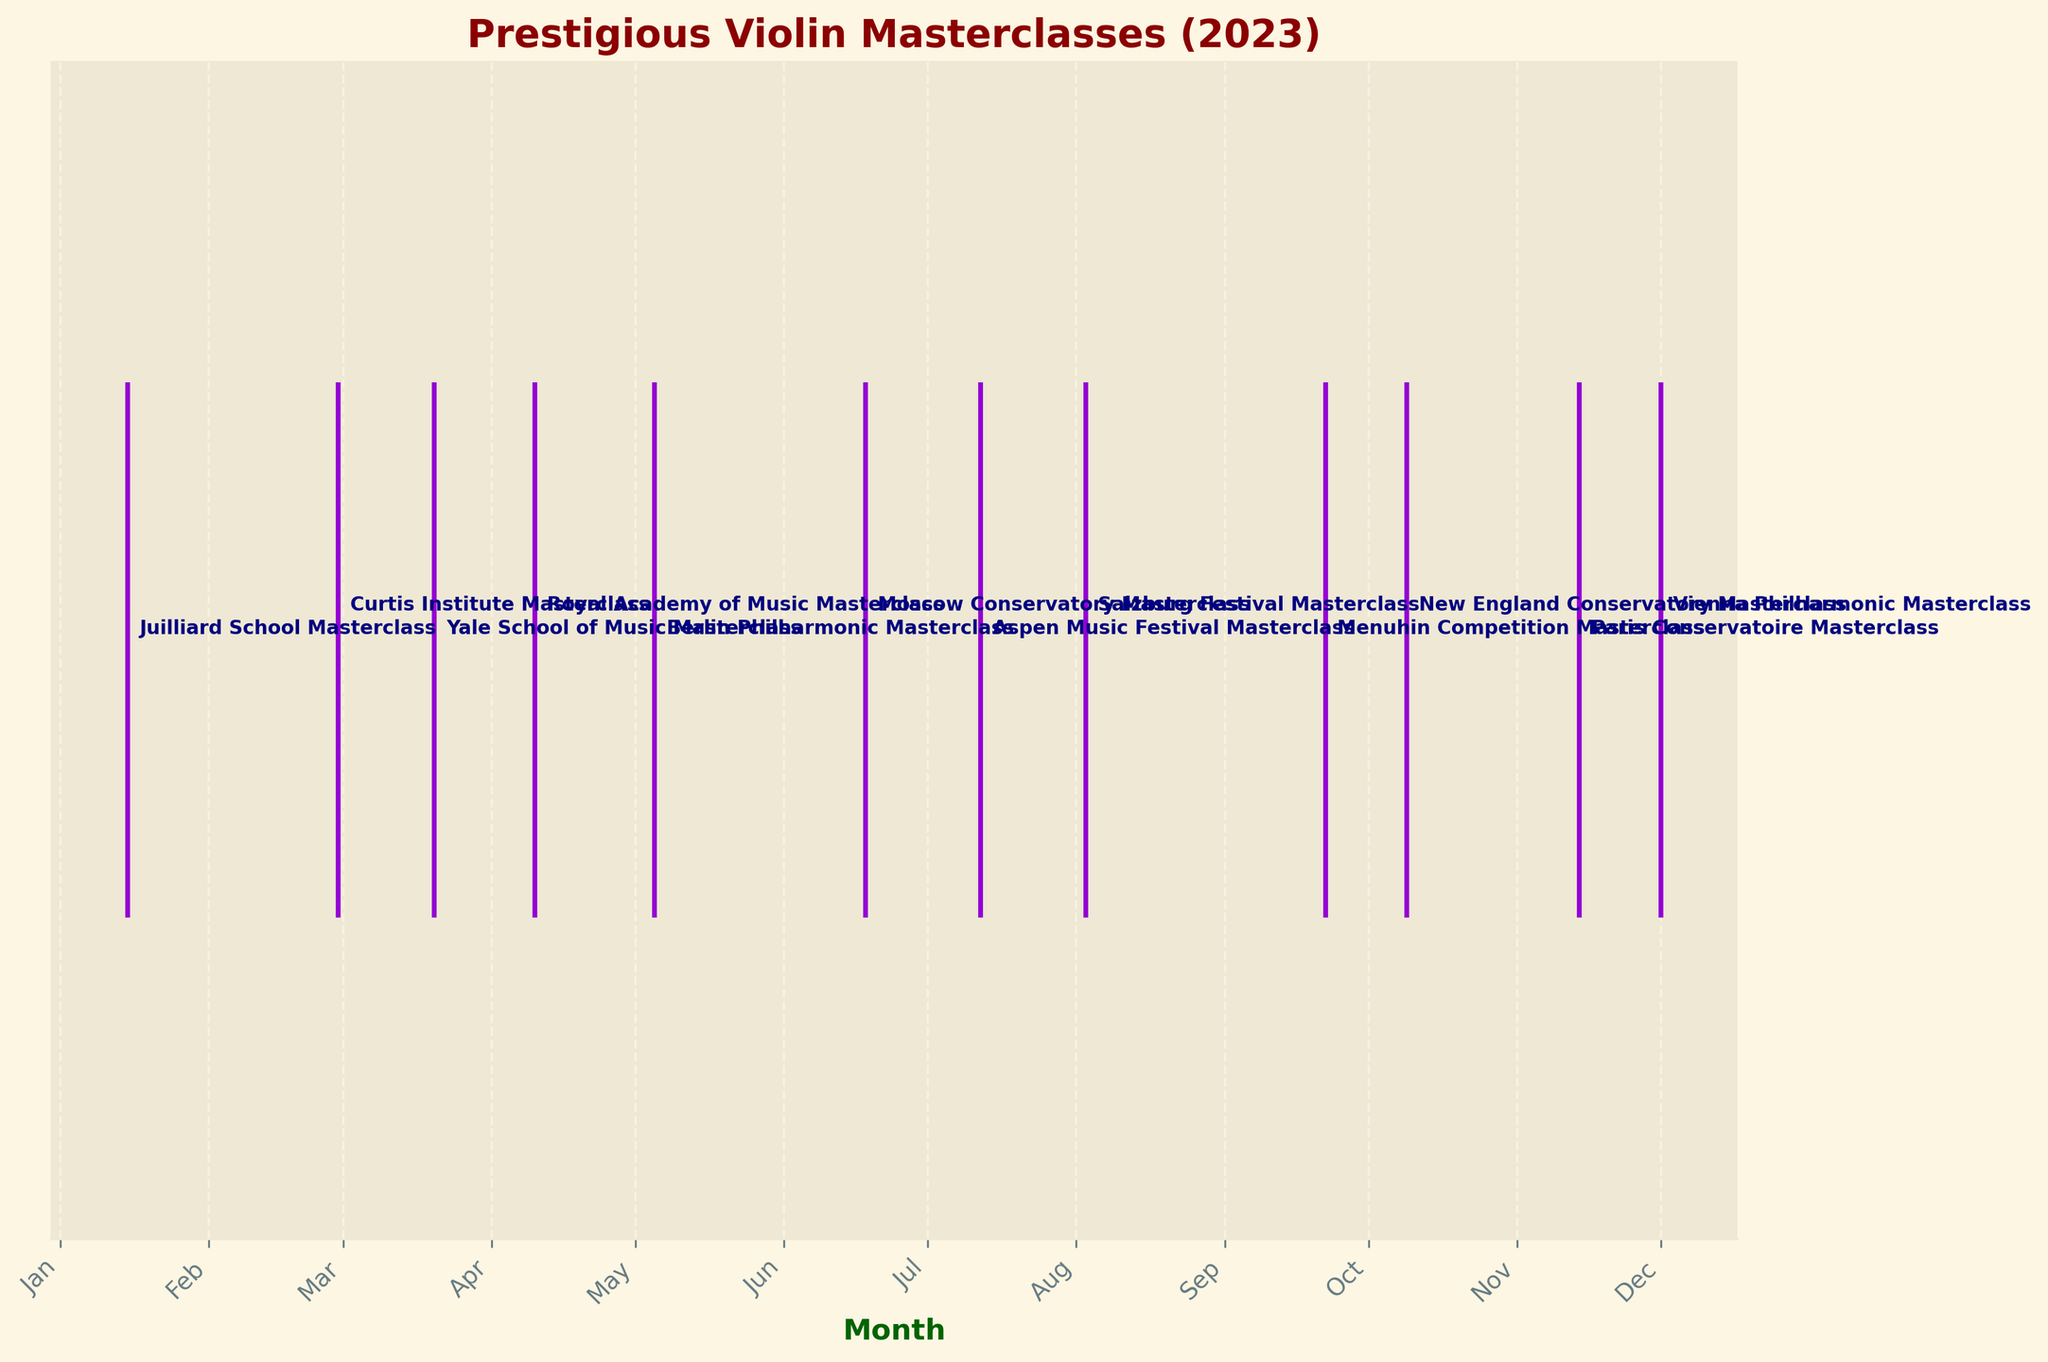What's the title of the plot? The title is usually placed at the top of the plot in a larger font size. In this case, it reads: 'Prestigious Violin Masterclasses (2023)'.
Answer: Prestigious Violin Masterclasses (2023) Which masterclass event happened in June? The annotated labels next to the event line in June are readable. The label for June corresponds to 'Moscow Conservatory Masterclass'.
Answer: Moscow Conservatory Masterclass How many masterclasses are shown in the figure? Each colored line in the eventplot represents a masterclass event. Counting these lines gives us a total of 12 masterclasses.
Answer: 12 Which month has the first masterclass of the year? The masterclasses are sorted in chronological order. The first event appears in January, which is indicated by the label 'Juilliard School Masterclass'.
Answer: January How many months have more than one event? Each month in the X-axis has one associated label. Since no months have more than one label annotated, no months have more than one event.
Answer: 0 Which event is closest to the middle of the year? The middle of the year is around June. Checking the months closest to June, we see that the 'Moscow Conservatory Masterclass' in June is the event that falls in the middle.
Answer: Moscow Conservatory Masterclass How many masterclasses take place after August? Events after August are annotated under the months of September, October, November, and December. Counting these, we find a total of 4 events after August.
Answer: 4 Which masterclass takes place just before the New England Conservatory Masterclass? Looking at the events before October (the month under which the New England Conservatory Masterclass is annotated), the previous month with an event is September (Menuhin Competition Masterclass).
Answer: Menuhin Competition Masterclass What is the time gap between the Berlin Philharmonic Masterclass and the Moscow Conservatory Masterclass? The Berlin Philharmonic Masterclass occurs in May and the Moscow Conservatory Masterclass in June, leading to a gap of roughly one month.
Answer: About 1 month 